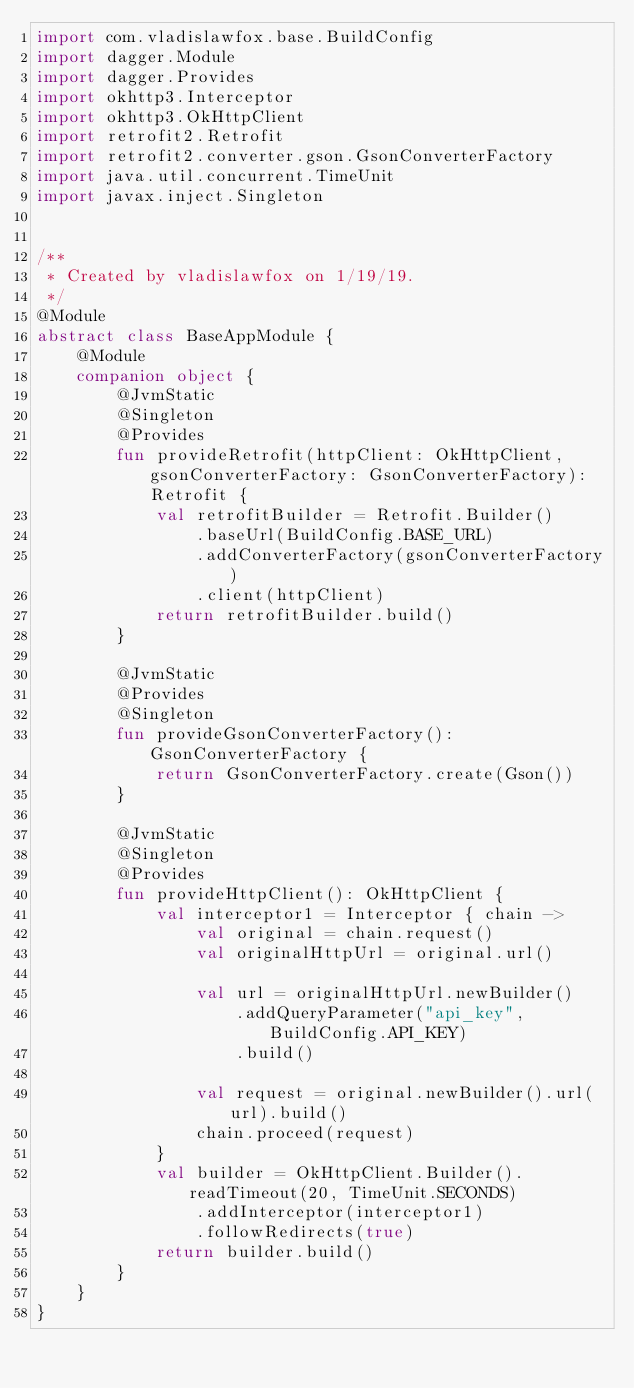<code> <loc_0><loc_0><loc_500><loc_500><_Kotlin_>import com.vladislawfox.base.BuildConfig
import dagger.Module
import dagger.Provides
import okhttp3.Interceptor
import okhttp3.OkHttpClient
import retrofit2.Retrofit
import retrofit2.converter.gson.GsonConverterFactory
import java.util.concurrent.TimeUnit
import javax.inject.Singleton


/**
 * Created by vladislawfox on 1/19/19.
 */
@Module
abstract class BaseAppModule {
    @Module
    companion object {
        @JvmStatic
        @Singleton
        @Provides
        fun provideRetrofit(httpClient: OkHttpClient, gsonConverterFactory: GsonConverterFactory): Retrofit {
            val retrofitBuilder = Retrofit.Builder()
                .baseUrl(BuildConfig.BASE_URL)
                .addConverterFactory(gsonConverterFactory)
                .client(httpClient)
            return retrofitBuilder.build()
        }

        @JvmStatic
        @Provides
        @Singleton
        fun provideGsonConverterFactory(): GsonConverterFactory {
            return GsonConverterFactory.create(Gson())
        }

        @JvmStatic
        @Singleton
        @Provides
        fun provideHttpClient(): OkHttpClient {
            val interceptor1 = Interceptor { chain ->
                val original = chain.request()
                val originalHttpUrl = original.url()

                val url = originalHttpUrl.newBuilder()
                    .addQueryParameter("api_key", BuildConfig.API_KEY)
                    .build()

                val request = original.newBuilder().url(url).build()
                chain.proceed(request)
            }
            val builder = OkHttpClient.Builder().readTimeout(20, TimeUnit.SECONDS)
                .addInterceptor(interceptor1)
                .followRedirects(true)
            return builder.build()
        }
    }
}</code> 